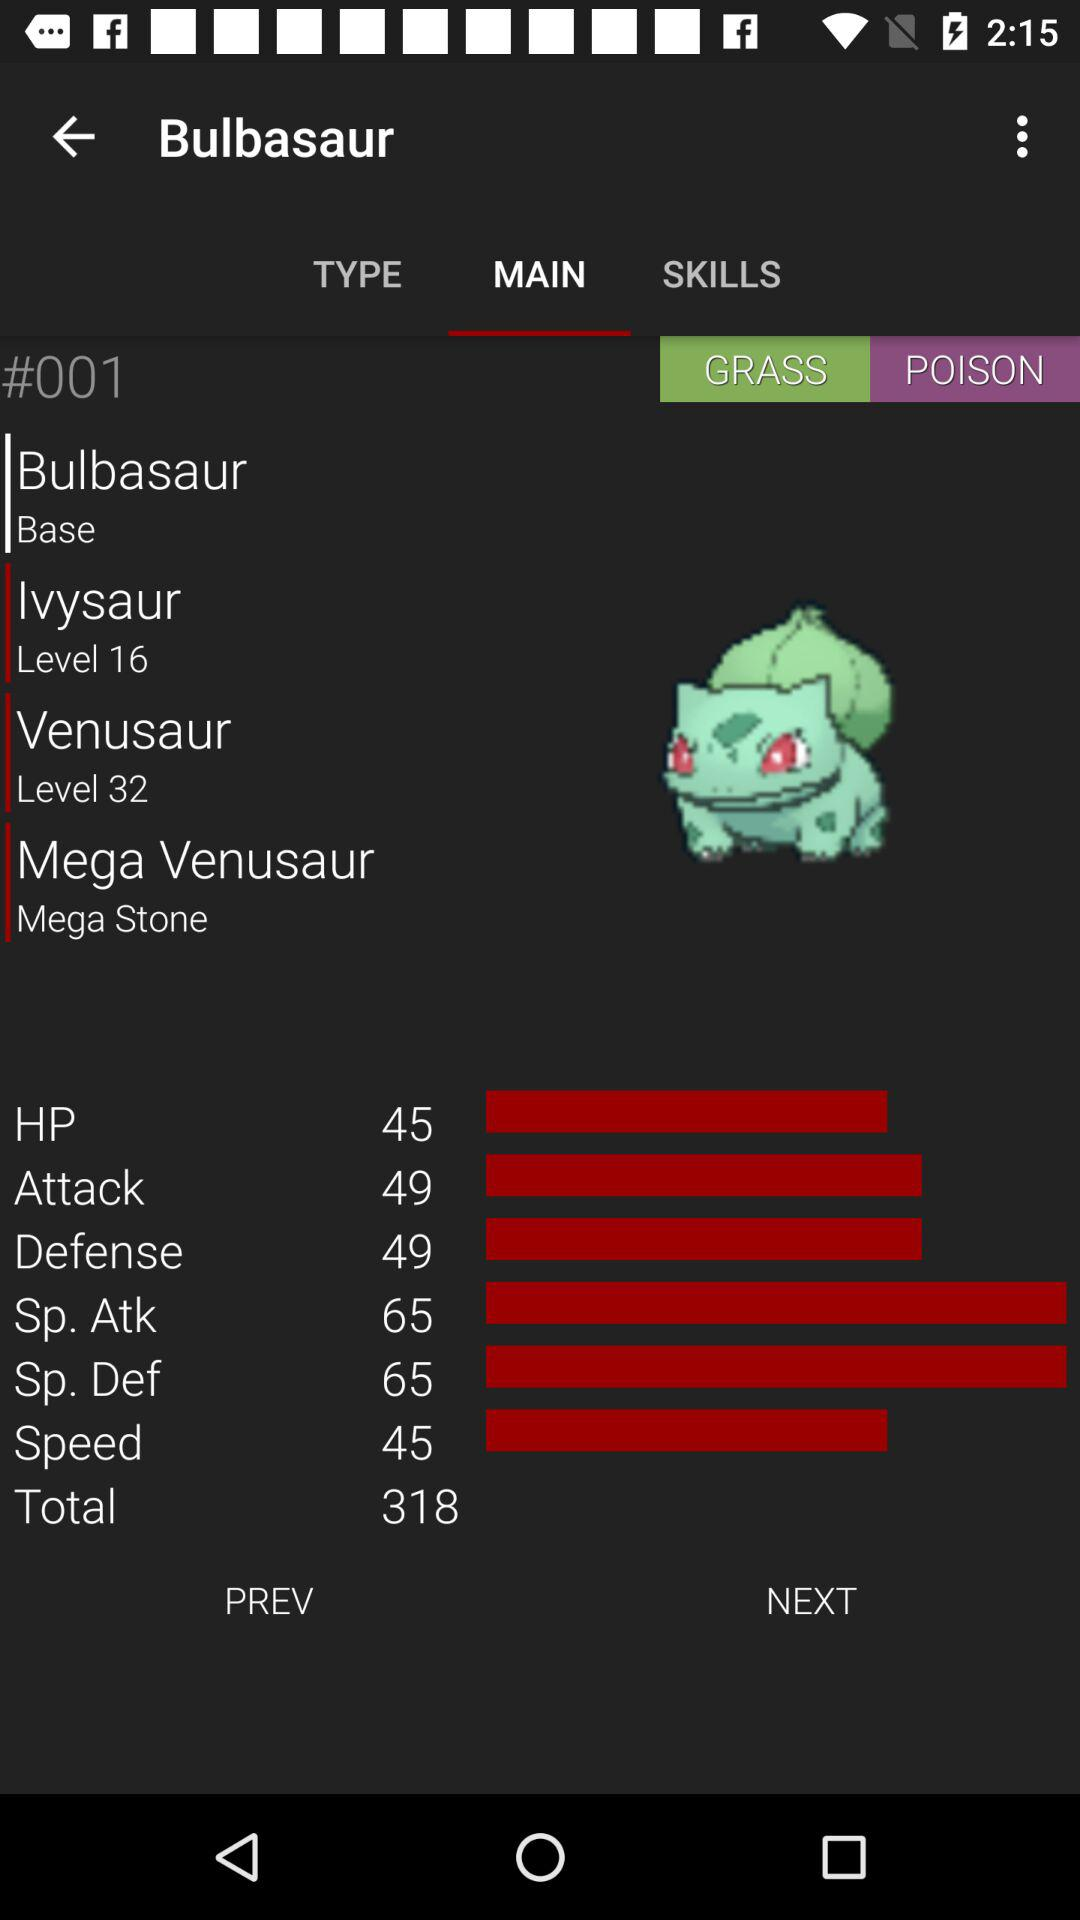What is the total score? The total score is 318. 